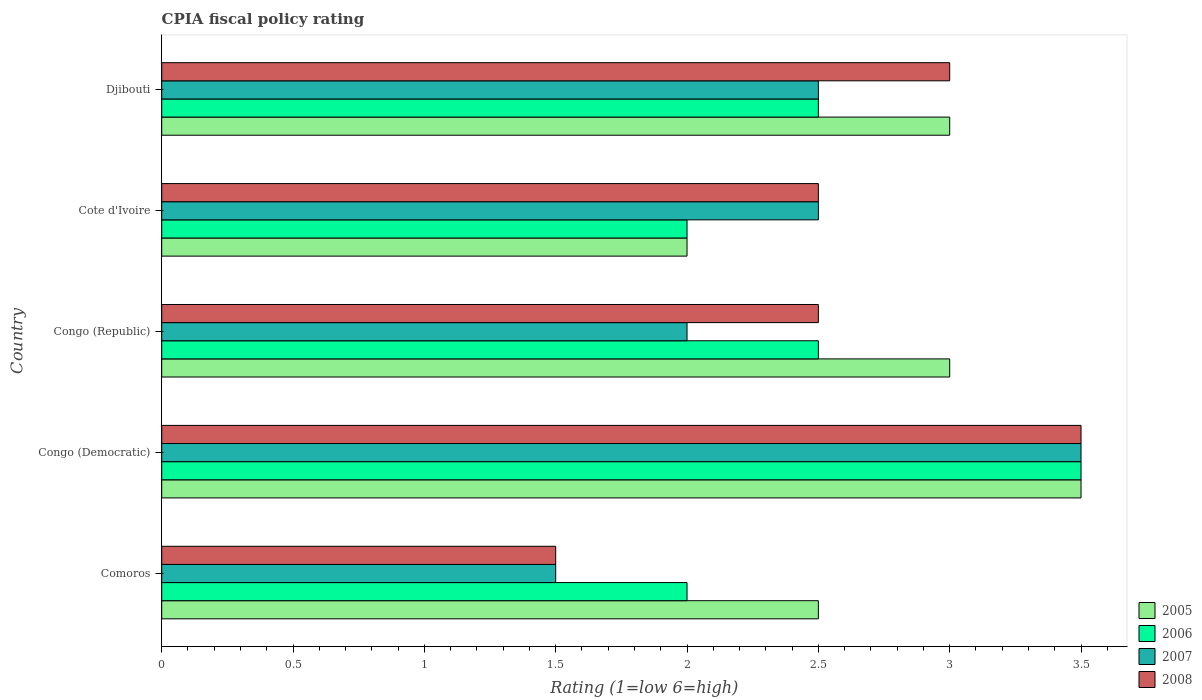How many different coloured bars are there?
Keep it short and to the point. 4. How many groups of bars are there?
Keep it short and to the point. 5. Are the number of bars per tick equal to the number of legend labels?
Offer a very short reply. Yes. Are the number of bars on each tick of the Y-axis equal?
Your answer should be very brief. Yes. How many bars are there on the 5th tick from the top?
Your answer should be compact. 4. How many bars are there on the 5th tick from the bottom?
Keep it short and to the point. 4. What is the label of the 3rd group of bars from the top?
Give a very brief answer. Congo (Republic). In how many cases, is the number of bars for a given country not equal to the number of legend labels?
Your response must be concise. 0. Across all countries, what is the maximum CPIA rating in 2007?
Make the answer very short. 3.5. In which country was the CPIA rating in 2006 maximum?
Provide a succinct answer. Congo (Democratic). In which country was the CPIA rating in 2008 minimum?
Give a very brief answer. Comoros. What is the total CPIA rating in 2007 in the graph?
Ensure brevity in your answer.  12. What is the ratio of the CPIA rating in 2007 in Congo (Democratic) to that in Cote d'Ivoire?
Provide a short and direct response. 1.4. What is the difference between the highest and the lowest CPIA rating in 2007?
Make the answer very short. 2. In how many countries, is the CPIA rating in 2008 greater than the average CPIA rating in 2008 taken over all countries?
Provide a succinct answer. 2. Is it the case that in every country, the sum of the CPIA rating in 2007 and CPIA rating in 2005 is greater than the sum of CPIA rating in 2006 and CPIA rating in 2008?
Your response must be concise. No. What does the 2nd bar from the top in Congo (Democratic) represents?
Offer a terse response. 2007. What does the 1st bar from the bottom in Comoros represents?
Your answer should be compact. 2005. Is it the case that in every country, the sum of the CPIA rating in 2006 and CPIA rating in 2005 is greater than the CPIA rating in 2008?
Offer a very short reply. Yes. What is the title of the graph?
Your answer should be compact. CPIA fiscal policy rating. What is the label or title of the X-axis?
Your answer should be very brief. Rating (1=low 6=high). What is the label or title of the Y-axis?
Provide a succinct answer. Country. What is the Rating (1=low 6=high) of 2007 in Comoros?
Provide a short and direct response. 1.5. What is the Rating (1=low 6=high) in 2008 in Comoros?
Offer a terse response. 1.5. What is the Rating (1=low 6=high) of 2005 in Congo (Democratic)?
Offer a terse response. 3.5. What is the Rating (1=low 6=high) in 2006 in Congo (Democratic)?
Your answer should be very brief. 3.5. What is the Rating (1=low 6=high) of 2008 in Congo (Democratic)?
Offer a very short reply. 3.5. What is the Rating (1=low 6=high) of 2005 in Congo (Republic)?
Keep it short and to the point. 3. What is the Rating (1=low 6=high) in 2006 in Congo (Republic)?
Make the answer very short. 2.5. What is the Rating (1=low 6=high) in 2007 in Congo (Republic)?
Offer a terse response. 2. What is the Rating (1=low 6=high) in 2008 in Congo (Republic)?
Offer a terse response. 2.5. What is the Rating (1=low 6=high) of 2005 in Cote d'Ivoire?
Your response must be concise. 2. What is the Rating (1=low 6=high) in 2006 in Cote d'Ivoire?
Keep it short and to the point. 2. What is the Rating (1=low 6=high) in 2007 in Cote d'Ivoire?
Offer a very short reply. 2.5. What is the Rating (1=low 6=high) in 2008 in Cote d'Ivoire?
Your response must be concise. 2.5. What is the Rating (1=low 6=high) of 2005 in Djibouti?
Give a very brief answer. 3. What is the Rating (1=low 6=high) of 2007 in Djibouti?
Provide a succinct answer. 2.5. What is the Rating (1=low 6=high) in 2008 in Djibouti?
Offer a terse response. 3. Across all countries, what is the maximum Rating (1=low 6=high) of 2005?
Offer a very short reply. 3.5. Across all countries, what is the maximum Rating (1=low 6=high) in 2006?
Offer a very short reply. 3.5. Across all countries, what is the maximum Rating (1=low 6=high) in 2007?
Give a very brief answer. 3.5. Across all countries, what is the maximum Rating (1=low 6=high) of 2008?
Offer a very short reply. 3.5. Across all countries, what is the minimum Rating (1=low 6=high) in 2005?
Keep it short and to the point. 2. Across all countries, what is the minimum Rating (1=low 6=high) in 2007?
Your answer should be compact. 1.5. Across all countries, what is the minimum Rating (1=low 6=high) of 2008?
Ensure brevity in your answer.  1.5. What is the total Rating (1=low 6=high) of 2005 in the graph?
Ensure brevity in your answer.  14. What is the total Rating (1=low 6=high) of 2006 in the graph?
Your answer should be very brief. 12.5. What is the total Rating (1=low 6=high) in 2007 in the graph?
Provide a short and direct response. 12. What is the difference between the Rating (1=low 6=high) in 2005 in Comoros and that in Congo (Democratic)?
Your answer should be compact. -1. What is the difference between the Rating (1=low 6=high) of 2006 in Comoros and that in Congo (Democratic)?
Provide a succinct answer. -1.5. What is the difference between the Rating (1=low 6=high) in 2008 in Comoros and that in Congo (Democratic)?
Give a very brief answer. -2. What is the difference between the Rating (1=low 6=high) in 2007 in Comoros and that in Congo (Republic)?
Make the answer very short. -0.5. What is the difference between the Rating (1=low 6=high) of 2008 in Comoros and that in Congo (Republic)?
Give a very brief answer. -1. What is the difference between the Rating (1=low 6=high) of 2005 in Comoros and that in Cote d'Ivoire?
Your answer should be very brief. 0.5. What is the difference between the Rating (1=low 6=high) in 2008 in Comoros and that in Cote d'Ivoire?
Make the answer very short. -1. What is the difference between the Rating (1=low 6=high) in 2006 in Comoros and that in Djibouti?
Provide a short and direct response. -0.5. What is the difference between the Rating (1=low 6=high) in 2008 in Comoros and that in Djibouti?
Provide a succinct answer. -1.5. What is the difference between the Rating (1=low 6=high) in 2008 in Congo (Democratic) and that in Congo (Republic)?
Your answer should be compact. 1. What is the difference between the Rating (1=low 6=high) in 2005 in Congo (Democratic) and that in Cote d'Ivoire?
Provide a short and direct response. 1.5. What is the difference between the Rating (1=low 6=high) in 2007 in Congo (Democratic) and that in Cote d'Ivoire?
Give a very brief answer. 1. What is the difference between the Rating (1=low 6=high) of 2005 in Congo (Democratic) and that in Djibouti?
Offer a terse response. 0.5. What is the difference between the Rating (1=low 6=high) in 2007 in Congo (Democratic) and that in Djibouti?
Your answer should be very brief. 1. What is the difference between the Rating (1=low 6=high) of 2008 in Congo (Democratic) and that in Djibouti?
Offer a very short reply. 0.5. What is the difference between the Rating (1=low 6=high) of 2005 in Congo (Republic) and that in Cote d'Ivoire?
Give a very brief answer. 1. What is the difference between the Rating (1=low 6=high) in 2007 in Congo (Republic) and that in Cote d'Ivoire?
Your answer should be compact. -0.5. What is the difference between the Rating (1=low 6=high) of 2005 in Congo (Republic) and that in Djibouti?
Provide a succinct answer. 0. What is the difference between the Rating (1=low 6=high) of 2006 in Congo (Republic) and that in Djibouti?
Your answer should be very brief. 0. What is the difference between the Rating (1=low 6=high) of 2007 in Congo (Republic) and that in Djibouti?
Keep it short and to the point. -0.5. What is the difference between the Rating (1=low 6=high) of 2005 in Cote d'Ivoire and that in Djibouti?
Your answer should be compact. -1. What is the difference between the Rating (1=low 6=high) of 2006 in Cote d'Ivoire and that in Djibouti?
Provide a short and direct response. -0.5. What is the difference between the Rating (1=low 6=high) in 2007 in Cote d'Ivoire and that in Djibouti?
Offer a terse response. 0. What is the difference between the Rating (1=low 6=high) of 2008 in Cote d'Ivoire and that in Djibouti?
Your answer should be very brief. -0.5. What is the difference between the Rating (1=low 6=high) in 2005 in Comoros and the Rating (1=low 6=high) in 2006 in Congo (Democratic)?
Keep it short and to the point. -1. What is the difference between the Rating (1=low 6=high) in 2005 in Comoros and the Rating (1=low 6=high) in 2007 in Congo (Democratic)?
Offer a terse response. -1. What is the difference between the Rating (1=low 6=high) in 2005 in Comoros and the Rating (1=low 6=high) in 2008 in Congo (Democratic)?
Your response must be concise. -1. What is the difference between the Rating (1=low 6=high) of 2006 in Comoros and the Rating (1=low 6=high) of 2007 in Congo (Democratic)?
Keep it short and to the point. -1.5. What is the difference between the Rating (1=low 6=high) in 2006 in Comoros and the Rating (1=low 6=high) in 2008 in Congo (Republic)?
Your response must be concise. -0.5. What is the difference between the Rating (1=low 6=high) in 2005 in Comoros and the Rating (1=low 6=high) in 2007 in Cote d'Ivoire?
Give a very brief answer. 0. What is the difference between the Rating (1=low 6=high) in 2006 in Comoros and the Rating (1=low 6=high) in 2007 in Cote d'Ivoire?
Give a very brief answer. -0.5. What is the difference between the Rating (1=low 6=high) of 2006 in Comoros and the Rating (1=low 6=high) of 2008 in Cote d'Ivoire?
Your response must be concise. -0.5. What is the difference between the Rating (1=low 6=high) of 2006 in Comoros and the Rating (1=low 6=high) of 2007 in Djibouti?
Your answer should be compact. -0.5. What is the difference between the Rating (1=low 6=high) in 2006 in Comoros and the Rating (1=low 6=high) in 2008 in Djibouti?
Your answer should be very brief. -1. What is the difference between the Rating (1=low 6=high) in 2007 in Comoros and the Rating (1=low 6=high) in 2008 in Djibouti?
Provide a succinct answer. -1.5. What is the difference between the Rating (1=low 6=high) in 2005 in Congo (Democratic) and the Rating (1=low 6=high) in 2006 in Congo (Republic)?
Ensure brevity in your answer.  1. What is the difference between the Rating (1=low 6=high) of 2006 in Congo (Democratic) and the Rating (1=low 6=high) of 2008 in Congo (Republic)?
Your response must be concise. 1. What is the difference between the Rating (1=low 6=high) of 2006 in Congo (Democratic) and the Rating (1=low 6=high) of 2008 in Cote d'Ivoire?
Your answer should be very brief. 1. What is the difference between the Rating (1=low 6=high) in 2005 in Congo (Democratic) and the Rating (1=low 6=high) in 2006 in Djibouti?
Offer a very short reply. 1. What is the difference between the Rating (1=low 6=high) of 2005 in Congo (Democratic) and the Rating (1=low 6=high) of 2007 in Djibouti?
Ensure brevity in your answer.  1. What is the difference between the Rating (1=low 6=high) in 2006 in Congo (Democratic) and the Rating (1=low 6=high) in 2007 in Djibouti?
Your answer should be very brief. 1. What is the difference between the Rating (1=low 6=high) in 2006 in Congo (Democratic) and the Rating (1=low 6=high) in 2008 in Djibouti?
Offer a very short reply. 0.5. What is the difference between the Rating (1=low 6=high) of 2005 in Congo (Republic) and the Rating (1=low 6=high) of 2007 in Cote d'Ivoire?
Provide a succinct answer. 0.5. What is the difference between the Rating (1=low 6=high) of 2005 in Congo (Republic) and the Rating (1=low 6=high) of 2008 in Cote d'Ivoire?
Keep it short and to the point. 0.5. What is the difference between the Rating (1=low 6=high) of 2005 in Congo (Republic) and the Rating (1=low 6=high) of 2006 in Djibouti?
Offer a terse response. 0.5. What is the difference between the Rating (1=low 6=high) in 2005 in Congo (Republic) and the Rating (1=low 6=high) in 2008 in Djibouti?
Your answer should be very brief. 0. What is the difference between the Rating (1=low 6=high) of 2006 in Congo (Republic) and the Rating (1=low 6=high) of 2007 in Djibouti?
Your answer should be very brief. 0. What is the difference between the Rating (1=low 6=high) of 2005 in Cote d'Ivoire and the Rating (1=low 6=high) of 2006 in Djibouti?
Your response must be concise. -0.5. What is the difference between the Rating (1=low 6=high) in 2005 in Cote d'Ivoire and the Rating (1=low 6=high) in 2007 in Djibouti?
Offer a terse response. -0.5. What is the difference between the Rating (1=low 6=high) of 2005 in Cote d'Ivoire and the Rating (1=low 6=high) of 2008 in Djibouti?
Give a very brief answer. -1. What is the difference between the Rating (1=low 6=high) of 2006 in Cote d'Ivoire and the Rating (1=low 6=high) of 2008 in Djibouti?
Ensure brevity in your answer.  -1. What is the difference between the Rating (1=low 6=high) in 2007 in Cote d'Ivoire and the Rating (1=low 6=high) in 2008 in Djibouti?
Give a very brief answer. -0.5. What is the average Rating (1=low 6=high) in 2008 per country?
Your response must be concise. 2.6. What is the difference between the Rating (1=low 6=high) in 2005 and Rating (1=low 6=high) in 2008 in Comoros?
Provide a short and direct response. 1. What is the difference between the Rating (1=low 6=high) of 2006 and Rating (1=low 6=high) of 2008 in Comoros?
Your response must be concise. 0.5. What is the difference between the Rating (1=low 6=high) of 2007 and Rating (1=low 6=high) of 2008 in Comoros?
Your answer should be very brief. 0. What is the difference between the Rating (1=low 6=high) in 2005 and Rating (1=low 6=high) in 2007 in Congo (Democratic)?
Provide a succinct answer. 0. What is the difference between the Rating (1=low 6=high) of 2006 and Rating (1=low 6=high) of 2007 in Congo (Democratic)?
Make the answer very short. 0. What is the difference between the Rating (1=low 6=high) in 2007 and Rating (1=low 6=high) in 2008 in Congo (Democratic)?
Your answer should be very brief. 0. What is the difference between the Rating (1=low 6=high) of 2005 and Rating (1=low 6=high) of 2008 in Congo (Republic)?
Ensure brevity in your answer.  0.5. What is the difference between the Rating (1=low 6=high) of 2005 and Rating (1=low 6=high) of 2007 in Cote d'Ivoire?
Offer a terse response. -0.5. What is the difference between the Rating (1=low 6=high) of 2005 and Rating (1=low 6=high) of 2008 in Cote d'Ivoire?
Make the answer very short. -0.5. What is the difference between the Rating (1=low 6=high) in 2006 and Rating (1=low 6=high) in 2008 in Cote d'Ivoire?
Ensure brevity in your answer.  -0.5. What is the difference between the Rating (1=low 6=high) of 2005 and Rating (1=low 6=high) of 2008 in Djibouti?
Give a very brief answer. 0. What is the difference between the Rating (1=low 6=high) in 2007 and Rating (1=low 6=high) in 2008 in Djibouti?
Make the answer very short. -0.5. What is the ratio of the Rating (1=low 6=high) of 2007 in Comoros to that in Congo (Democratic)?
Keep it short and to the point. 0.43. What is the ratio of the Rating (1=low 6=high) in 2008 in Comoros to that in Congo (Democratic)?
Give a very brief answer. 0.43. What is the ratio of the Rating (1=low 6=high) of 2006 in Comoros to that in Congo (Republic)?
Your answer should be compact. 0.8. What is the ratio of the Rating (1=low 6=high) in 2007 in Comoros to that in Congo (Republic)?
Offer a very short reply. 0.75. What is the ratio of the Rating (1=low 6=high) of 2008 in Comoros to that in Congo (Republic)?
Provide a succinct answer. 0.6. What is the ratio of the Rating (1=low 6=high) of 2005 in Comoros to that in Cote d'Ivoire?
Ensure brevity in your answer.  1.25. What is the ratio of the Rating (1=low 6=high) of 2007 in Comoros to that in Djibouti?
Offer a terse response. 0.6. What is the ratio of the Rating (1=low 6=high) of 2007 in Congo (Democratic) to that in Congo (Republic)?
Make the answer very short. 1.75. What is the ratio of the Rating (1=low 6=high) in 2008 in Congo (Democratic) to that in Congo (Republic)?
Offer a terse response. 1.4. What is the ratio of the Rating (1=low 6=high) in 2005 in Congo (Democratic) to that in Cote d'Ivoire?
Your response must be concise. 1.75. What is the ratio of the Rating (1=low 6=high) of 2006 in Congo (Democratic) to that in Cote d'Ivoire?
Keep it short and to the point. 1.75. What is the ratio of the Rating (1=low 6=high) in 2007 in Congo (Democratic) to that in Cote d'Ivoire?
Your answer should be compact. 1.4. What is the ratio of the Rating (1=low 6=high) of 2008 in Congo (Democratic) to that in Cote d'Ivoire?
Offer a terse response. 1.4. What is the ratio of the Rating (1=low 6=high) of 2005 in Congo (Democratic) to that in Djibouti?
Make the answer very short. 1.17. What is the ratio of the Rating (1=low 6=high) of 2008 in Congo (Democratic) to that in Djibouti?
Offer a very short reply. 1.17. What is the ratio of the Rating (1=low 6=high) of 2005 in Congo (Republic) to that in Cote d'Ivoire?
Keep it short and to the point. 1.5. What is the ratio of the Rating (1=low 6=high) of 2008 in Congo (Republic) to that in Cote d'Ivoire?
Give a very brief answer. 1. What is the ratio of the Rating (1=low 6=high) of 2005 in Congo (Republic) to that in Djibouti?
Your answer should be very brief. 1. What is the ratio of the Rating (1=low 6=high) of 2007 in Congo (Republic) to that in Djibouti?
Your answer should be very brief. 0.8. What is the ratio of the Rating (1=low 6=high) of 2008 in Congo (Republic) to that in Djibouti?
Your answer should be compact. 0.83. What is the ratio of the Rating (1=low 6=high) of 2005 in Cote d'Ivoire to that in Djibouti?
Provide a succinct answer. 0.67. What is the ratio of the Rating (1=low 6=high) of 2007 in Cote d'Ivoire to that in Djibouti?
Provide a succinct answer. 1. What is the difference between the highest and the second highest Rating (1=low 6=high) of 2006?
Give a very brief answer. 1. What is the difference between the highest and the second highest Rating (1=low 6=high) of 2007?
Ensure brevity in your answer.  1. What is the difference between the highest and the lowest Rating (1=low 6=high) of 2005?
Provide a short and direct response. 1.5. 